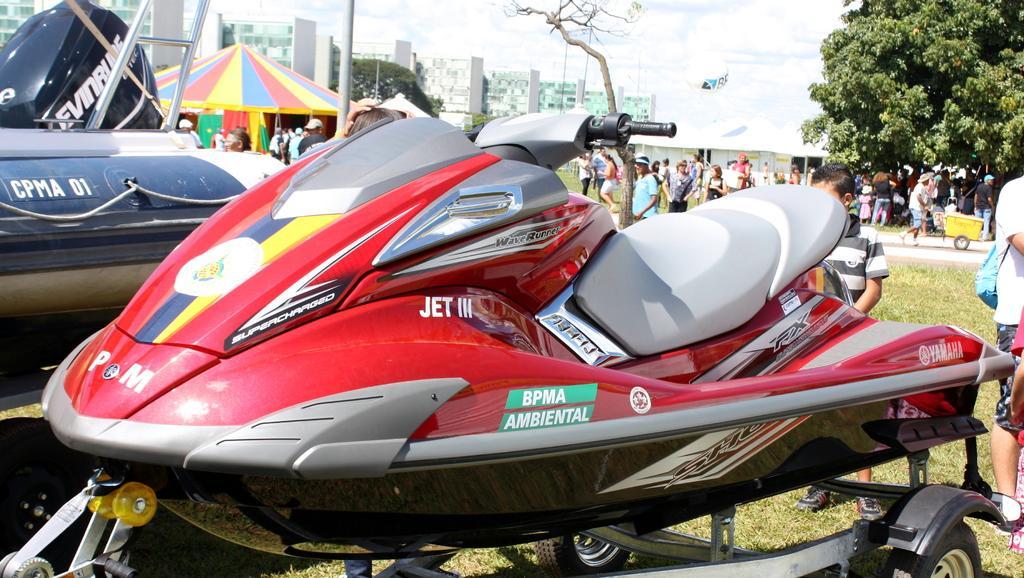How would you summarize this image in a sentence or two? There are vehicles with something written on that. In the back there are many people. Also there is a tent. Also there are buildings and trees. On the ground there is grass. 